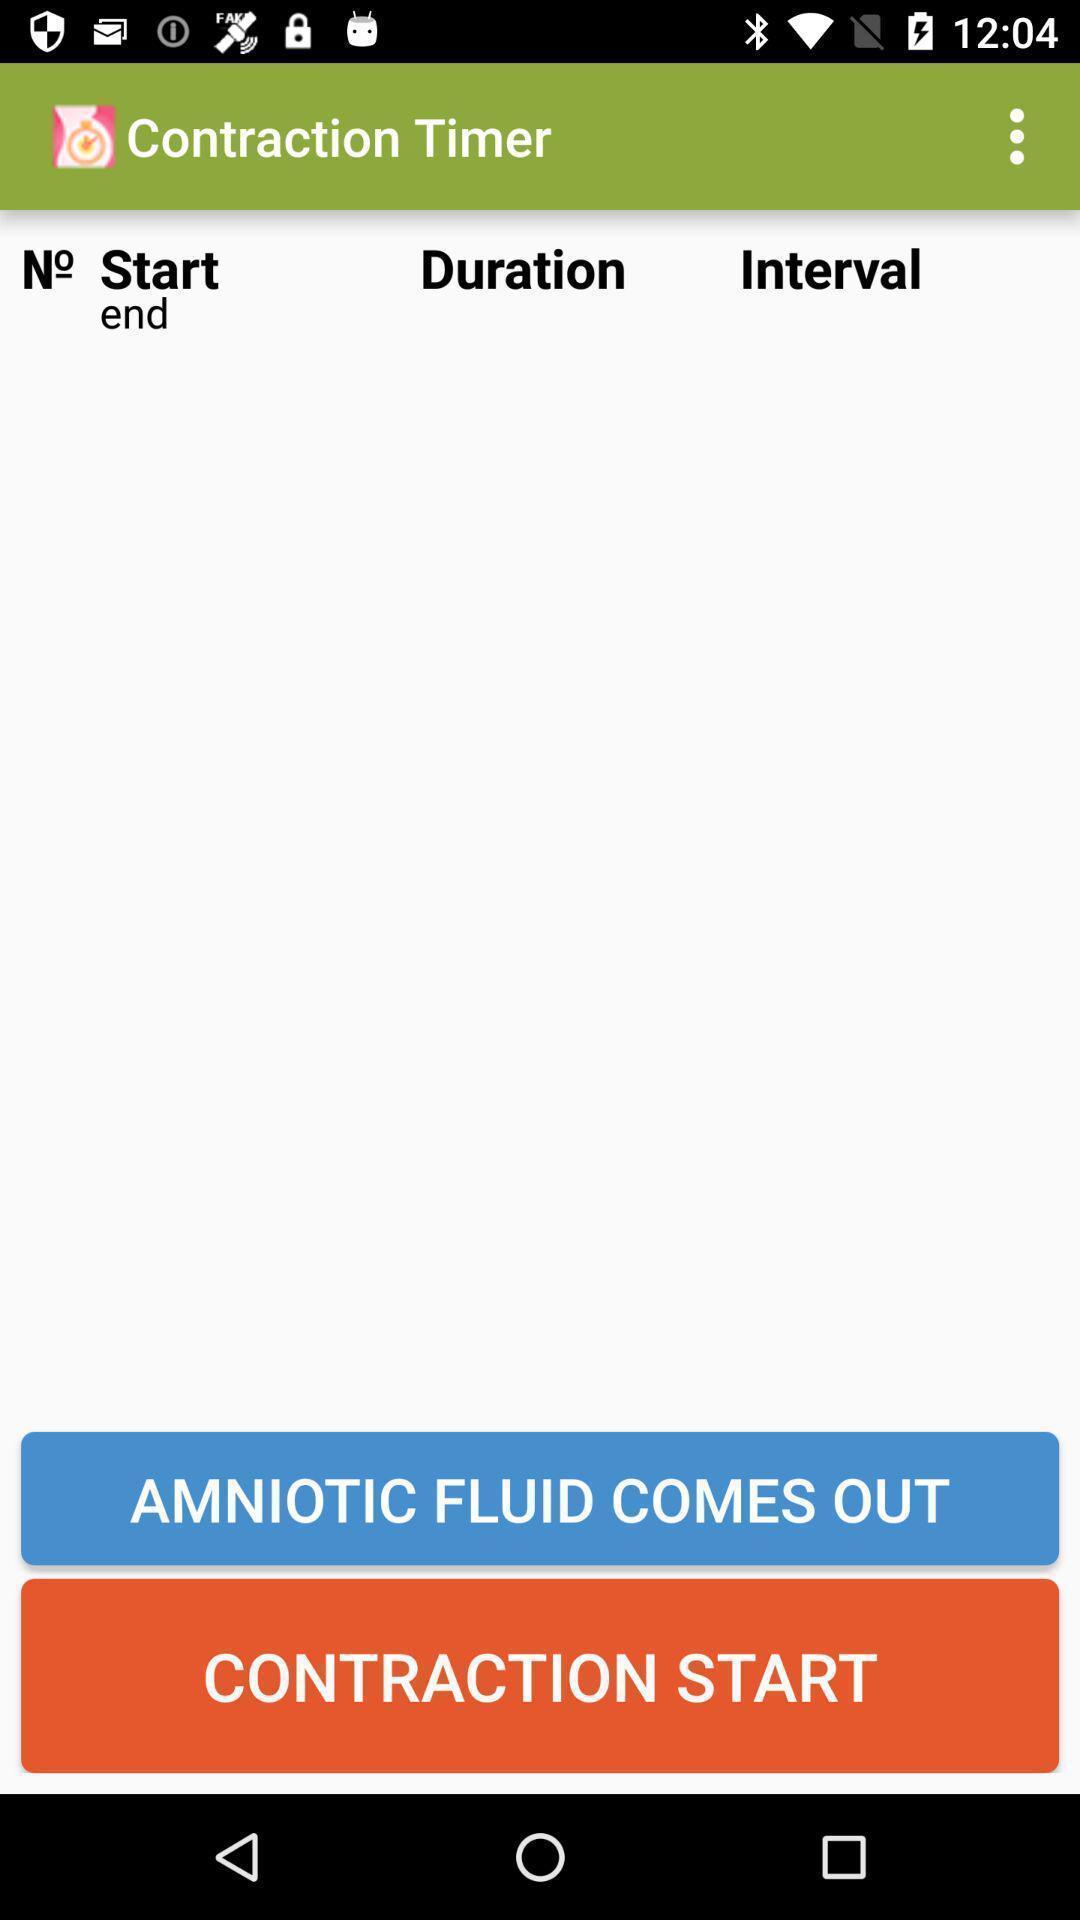Provide a textual representation of this image. Page displaying start and end time of a timer. 